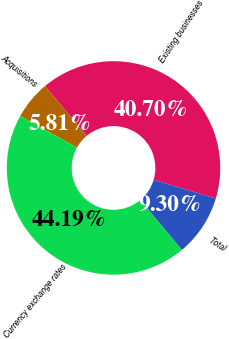Convert chart. <chart><loc_0><loc_0><loc_500><loc_500><pie_chart><fcel>Existing businesses<fcel>Acquisitions<fcel>Currency exchange rates<fcel>Total<nl><fcel>40.7%<fcel>5.81%<fcel>44.19%<fcel>9.3%<nl></chart> 